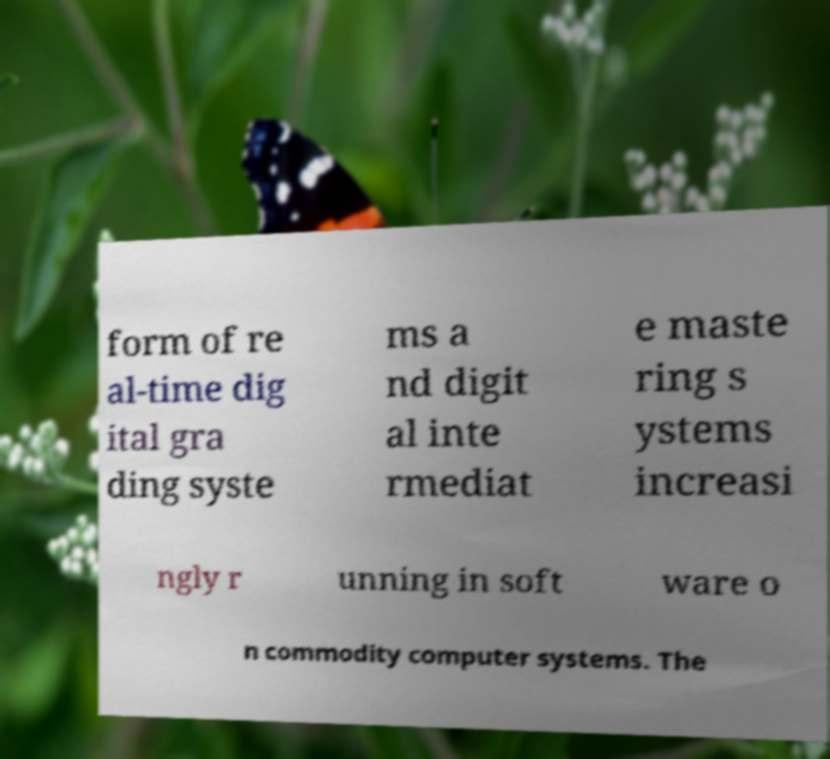For documentation purposes, I need the text within this image transcribed. Could you provide that? form of re al-time dig ital gra ding syste ms a nd digit al inte rmediat e maste ring s ystems increasi ngly r unning in soft ware o n commodity computer systems. The 